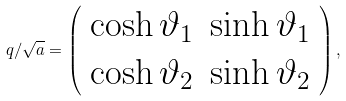<formula> <loc_0><loc_0><loc_500><loc_500>q / \sqrt { a } = \left ( \begin{array} { c c } \cosh \vartheta _ { 1 } & \sinh \vartheta _ { 1 } \\ \cosh \vartheta _ { 2 } & \sinh \vartheta _ { 2 } \\ \end{array} \right ) ,</formula> 